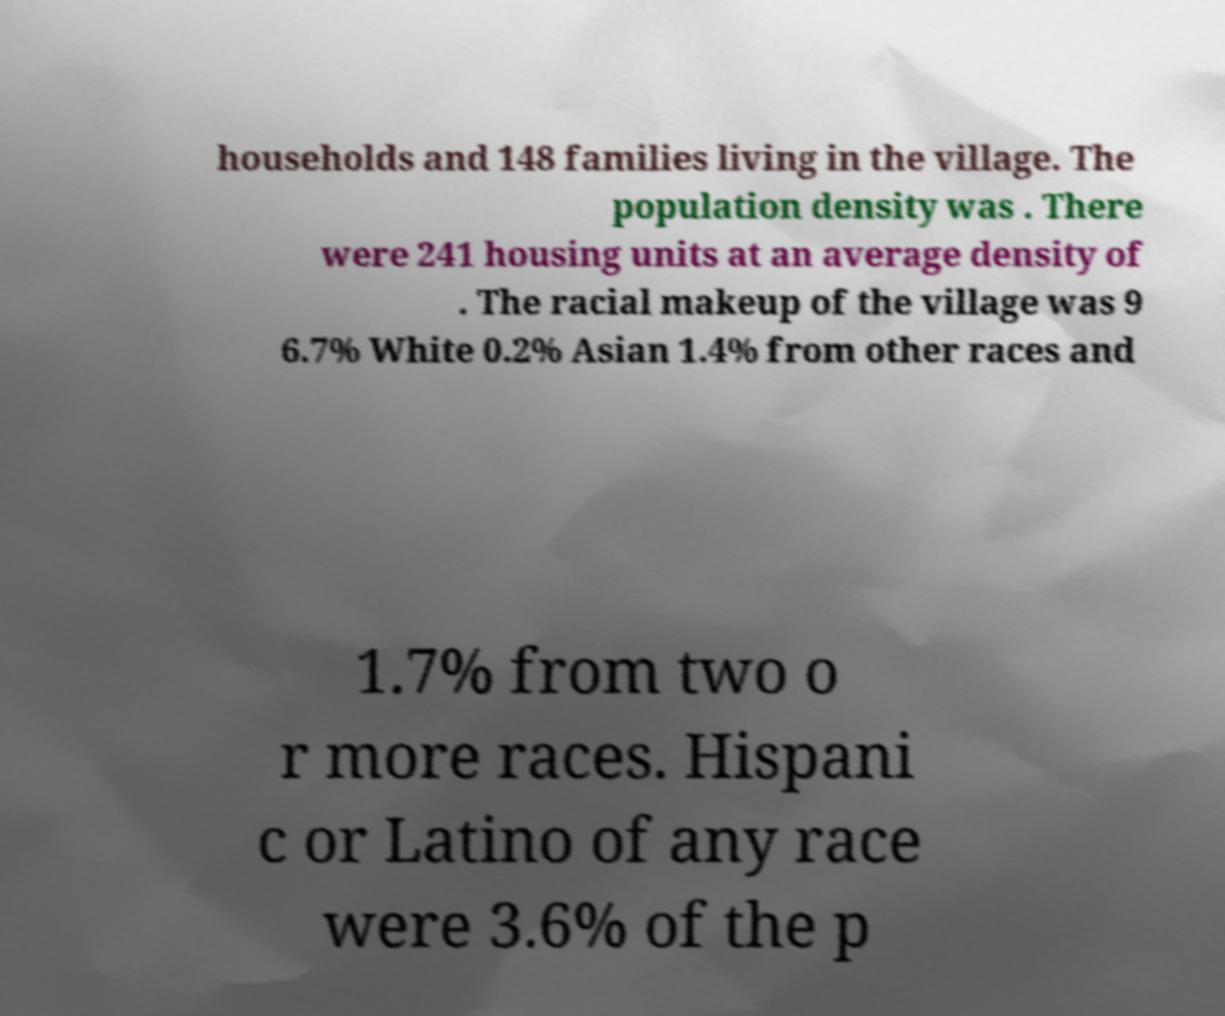What messages or text are displayed in this image? I need them in a readable, typed format. households and 148 families living in the village. The population density was . There were 241 housing units at an average density of . The racial makeup of the village was 9 6.7% White 0.2% Asian 1.4% from other races and 1.7% from two o r more races. Hispani c or Latino of any race were 3.6% of the p 